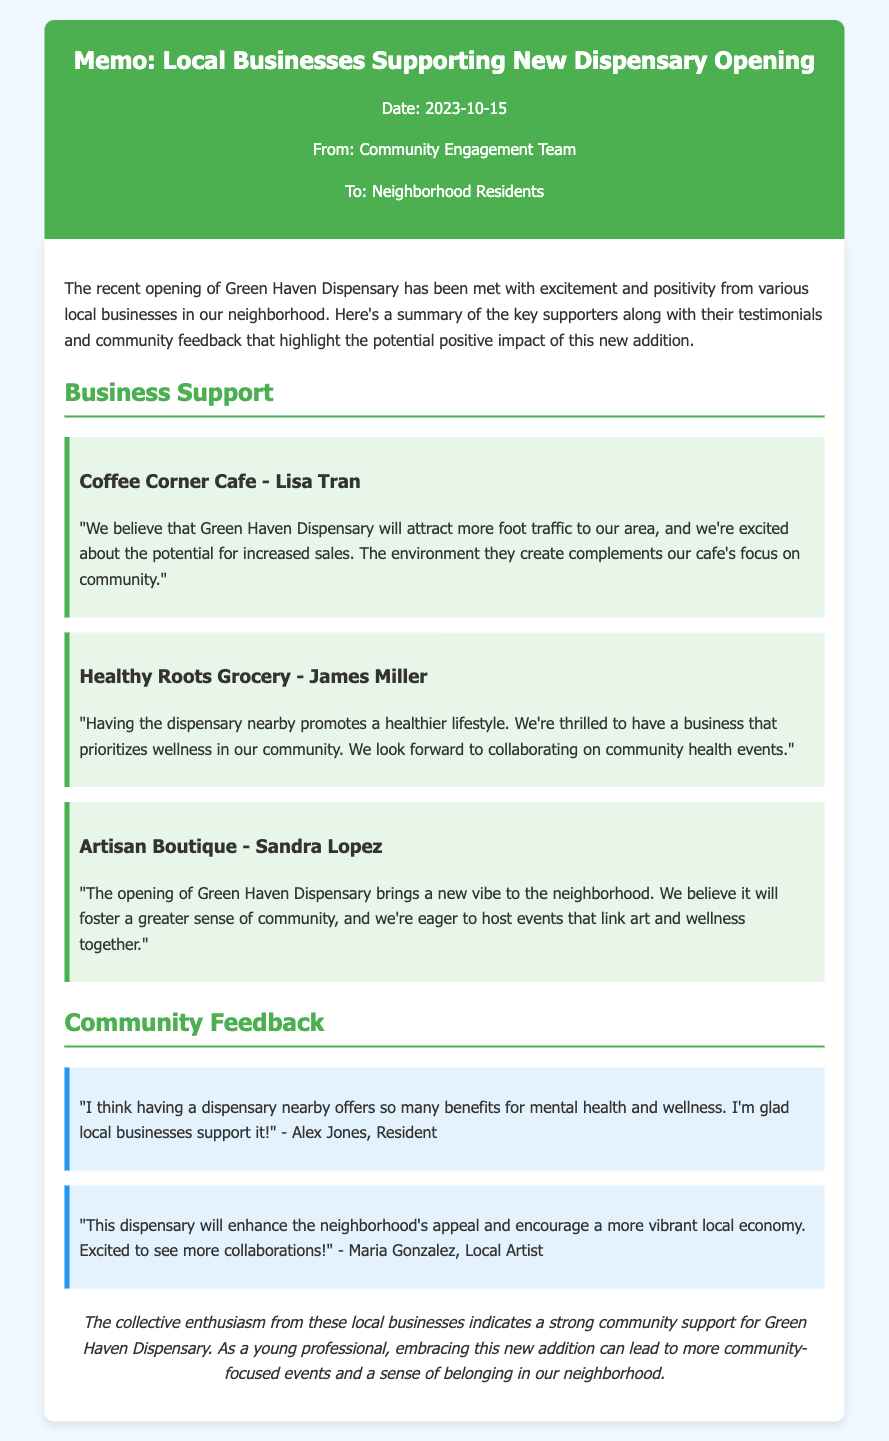What is the date of the memo? The date of the memo is stated at the top of the document.
Answer: 2023-10-15 Who is the representative from Coffee Corner Cafe? The document specifies the name of the person supporting from Coffee Corner Cafe.
Answer: Lisa Tran What business is excited about collaborating on community health events? The document mentions which local business looks forward to collaborating on health events.
Answer: Healthy Roots Grocery Which resident believes the dispensary will benefit mental health? A specific resident's opinion on the dispensary's benefits is mentioned in the feedback section.
Answer: Alex Jones What is the conclusion's sentiment towards the dispensary? The conclusion summarizes the overall community support for the new dispensary.
Answer: Enthusiasm 